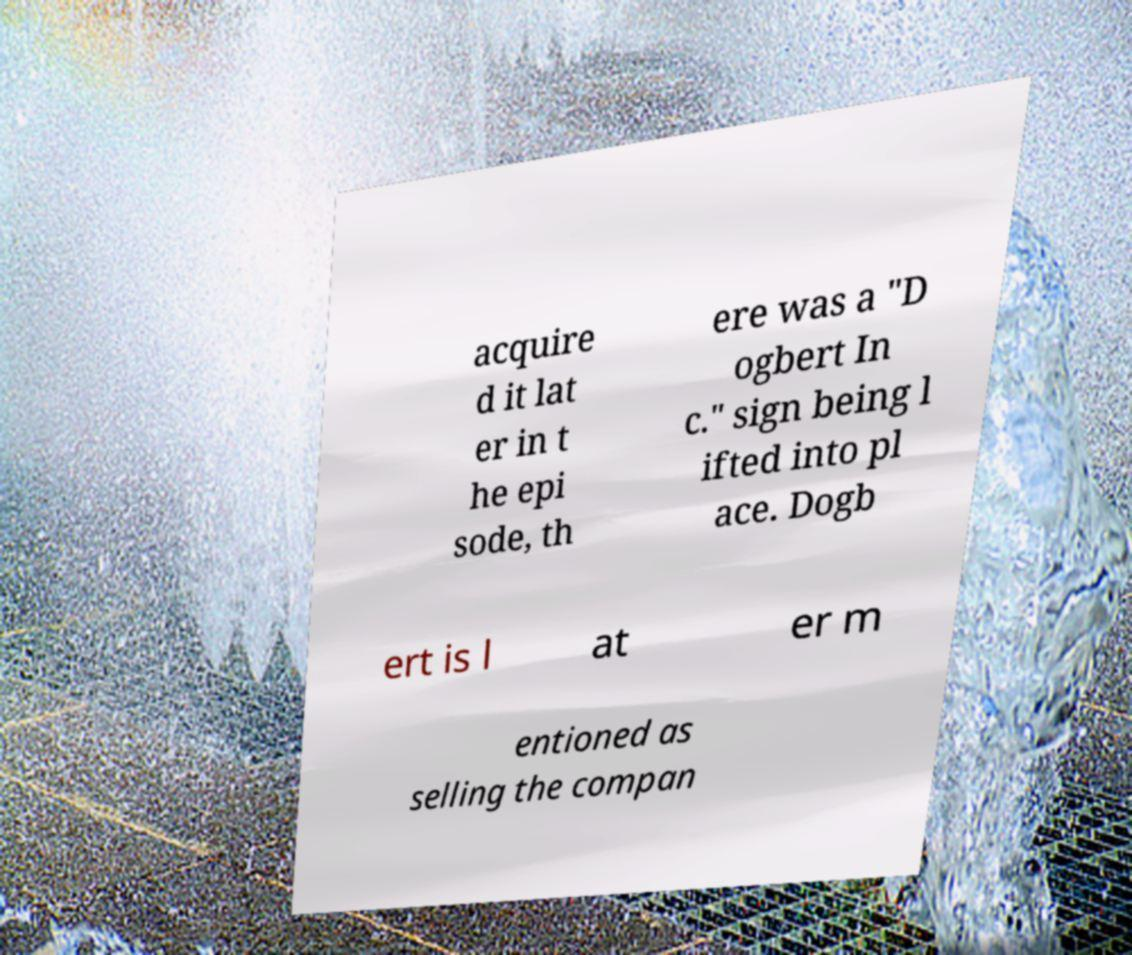Can you read and provide the text displayed in the image?This photo seems to have some interesting text. Can you extract and type it out for me? acquire d it lat er in t he epi sode, th ere was a "D ogbert In c." sign being l ifted into pl ace. Dogb ert is l at er m entioned as selling the compan 